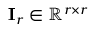<formula> <loc_0><loc_0><loc_500><loc_500>I _ { r } \in \mathbb { R } ^ { r \times r }</formula> 